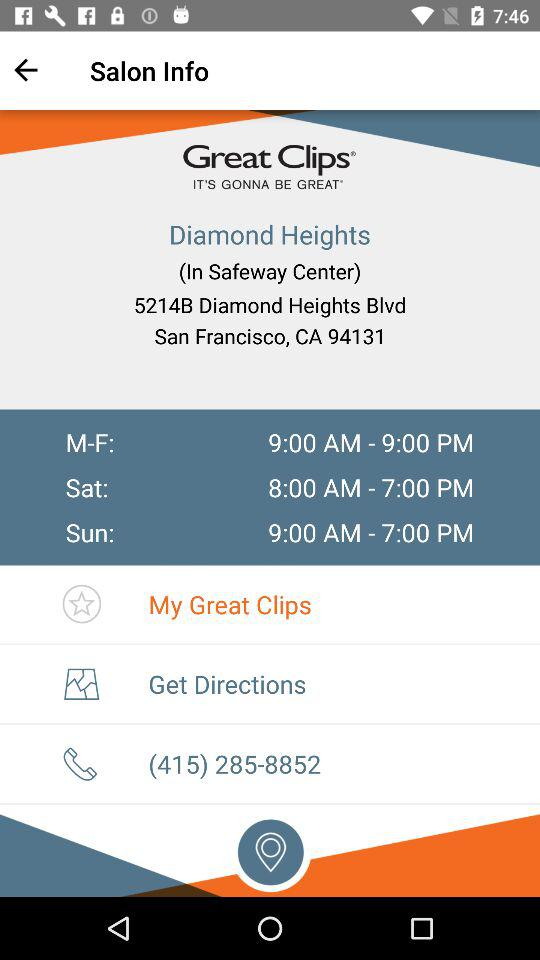What is the timing for Sunday? The timing for Sunday is from 9 a.m. to 7 p.m. 